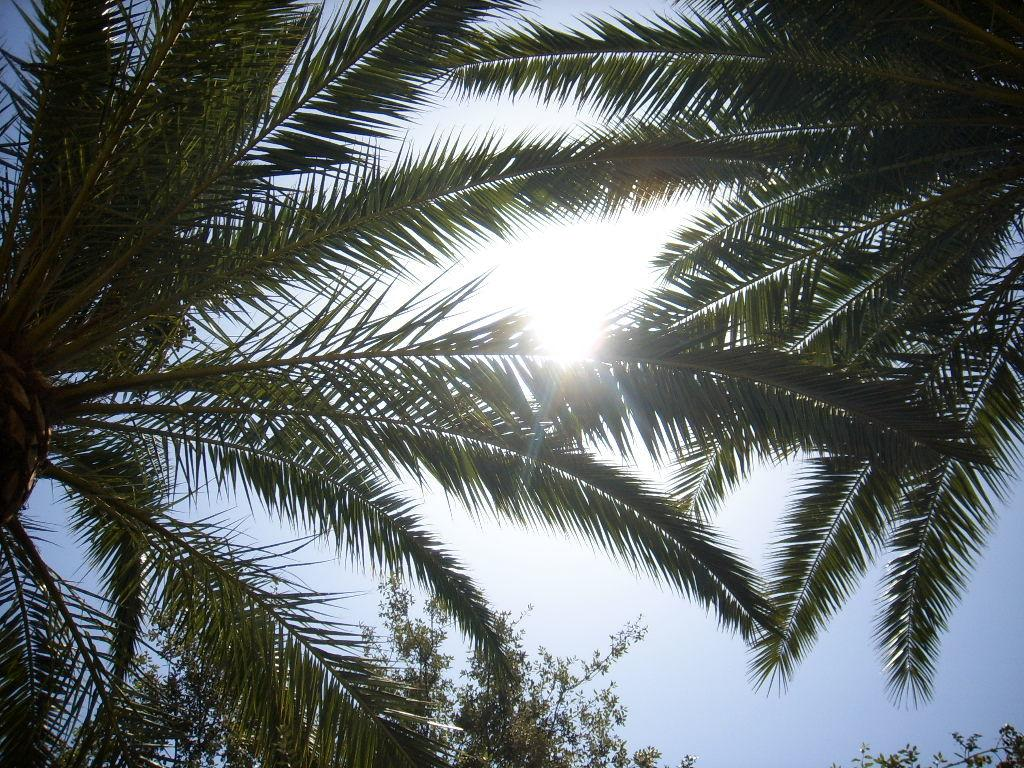What is the main subject in the center of the image? There are trees in the center of the image. What type of hat is hanging from the branches of the trees in the image? There is no hat present in the image; it only features trees. 